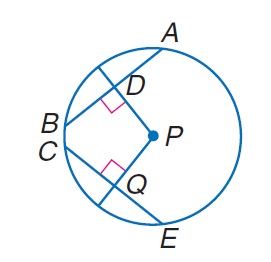Answer the mathemtical geometry problem and directly provide the correct option letter.
Question: In \odot P, P D = 10, P Q = 10, and Q E = 20, find P E.
Choices: A: 10 B: 20 C: 10 \sqrt { 5 } D: 30 C 